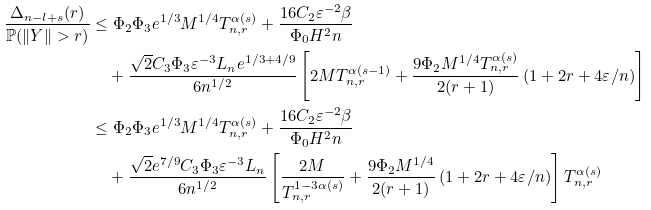Convert formula to latex. <formula><loc_0><loc_0><loc_500><loc_500>\frac { \Delta _ { n - l + s } ( r ) } { \mathbb { P } ( \| Y \| > r ) } & \leq \Phi _ { 2 } \Phi _ { 3 } e ^ { 1 / 3 } M ^ { 1 / 4 } T _ { n , r } ^ { \alpha ( s ) } + \frac { 1 6 C _ { 2 } \varepsilon ^ { - 2 } \beta } { \Phi _ { 0 } H ^ { 2 } n } \\ & \quad + \frac { \sqrt { 2 } C _ { 3 } \Phi _ { 3 } \varepsilon ^ { - 3 } L _ { n } e ^ { 1 / 3 + 4 / 9 } } { 6 n ^ { 1 / 2 } } \left [ 2 M T _ { n , r } ^ { \alpha ( s - 1 ) } + \frac { 9 \Phi _ { 2 } M ^ { 1 / 4 } T _ { n , r } ^ { \alpha ( s ) } } { 2 ( r + 1 ) } \left ( 1 + 2 r + { 4 \varepsilon } / { n } \right ) \right ] \\ & \leq \Phi _ { 2 } \Phi _ { 3 } e ^ { 1 / 3 } M ^ { 1 / 4 } T _ { n , r } ^ { \alpha ( s ) } + \frac { 1 6 C _ { 2 } \varepsilon ^ { - 2 } \beta } { \Phi _ { 0 } H ^ { 2 } n } \\ & \quad + \frac { \sqrt { 2 } e ^ { 7 / 9 } C _ { 3 } \Phi _ { 3 } \varepsilon ^ { - 3 } L _ { n } } { 6 n ^ { 1 / 2 } } \left [ \frac { 2 M } { T _ { n , r } ^ { 1 - 3 \alpha ( s ) } } + \frac { 9 \Phi _ { 2 } M ^ { 1 / 4 } } { 2 ( r + 1 ) } \left ( 1 + 2 r + { 4 \varepsilon } / { n } \right ) \right ] T _ { n , r } ^ { \alpha ( s ) }</formula> 